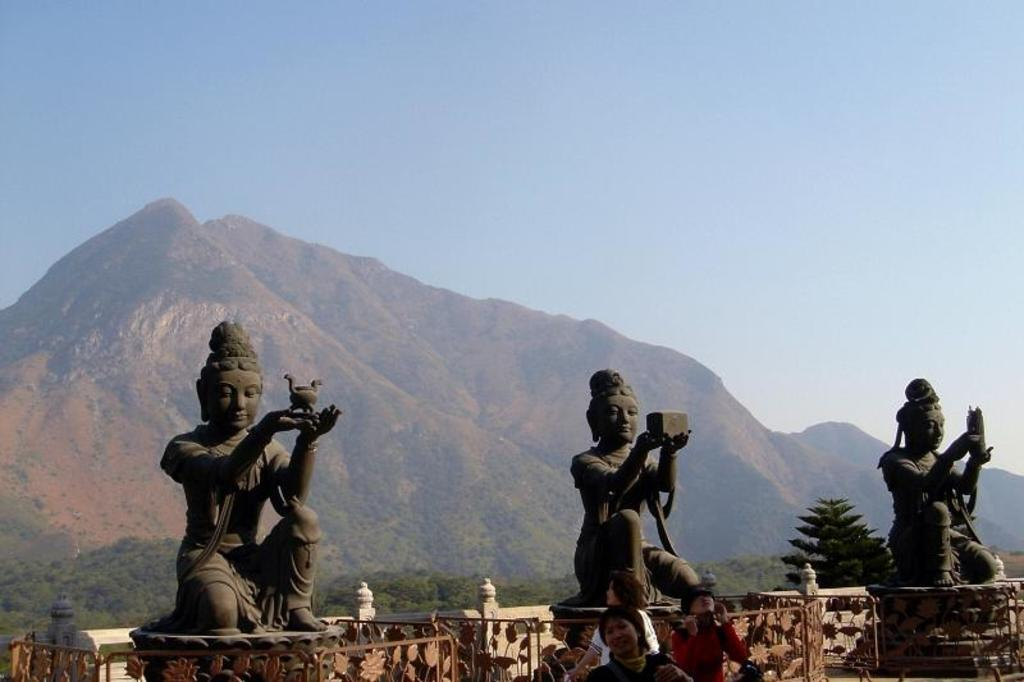What can be seen in the image that represents man-made structures or art? There are statues in the image. What type of natural elements are present in the image? There are trees and hills visible in the image. What is visible in the background of the image? The sky is visible in the background of the image. What feature can be seen at the bottom of the image? There are railings at the bottom of the image. Are there any living beings present in the image? Yes, there are people at the bottom of the image. Where is the drawer located in the image? There is no drawer present in the image. Is there a goat visible in the image? No, there is no goat present in the image. 